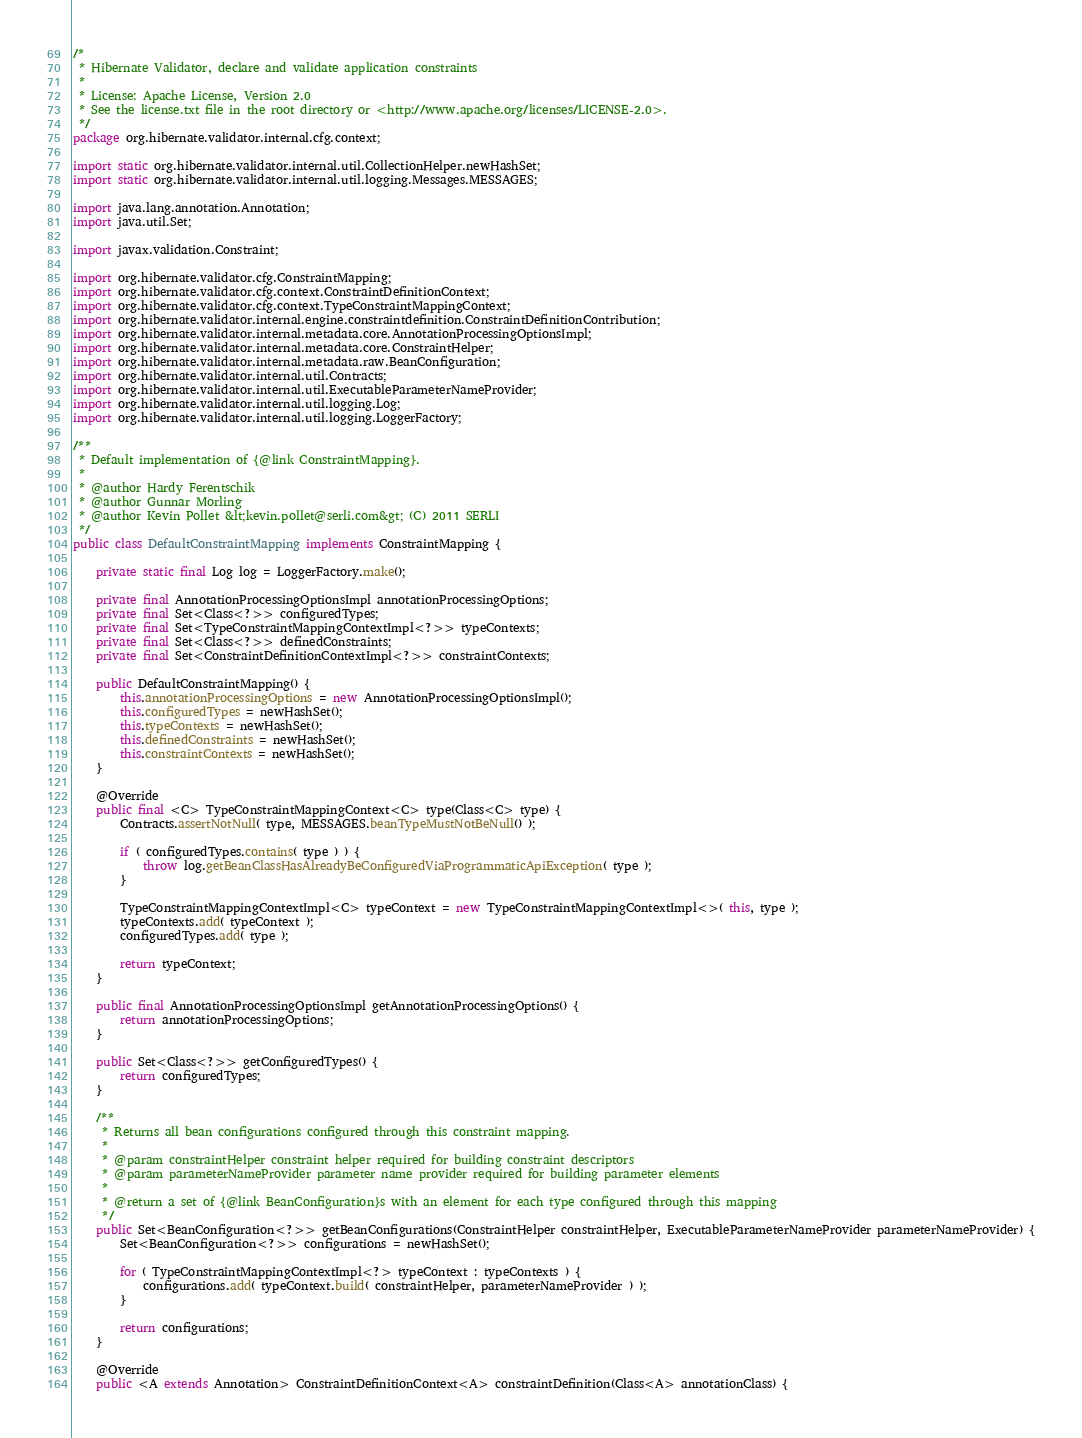<code> <loc_0><loc_0><loc_500><loc_500><_Java_>/*
 * Hibernate Validator, declare and validate application constraints
 *
 * License: Apache License, Version 2.0
 * See the license.txt file in the root directory or <http://www.apache.org/licenses/LICENSE-2.0>.
 */
package org.hibernate.validator.internal.cfg.context;

import static org.hibernate.validator.internal.util.CollectionHelper.newHashSet;
import static org.hibernate.validator.internal.util.logging.Messages.MESSAGES;

import java.lang.annotation.Annotation;
import java.util.Set;

import javax.validation.Constraint;

import org.hibernate.validator.cfg.ConstraintMapping;
import org.hibernate.validator.cfg.context.ConstraintDefinitionContext;
import org.hibernate.validator.cfg.context.TypeConstraintMappingContext;
import org.hibernate.validator.internal.engine.constraintdefinition.ConstraintDefinitionContribution;
import org.hibernate.validator.internal.metadata.core.AnnotationProcessingOptionsImpl;
import org.hibernate.validator.internal.metadata.core.ConstraintHelper;
import org.hibernate.validator.internal.metadata.raw.BeanConfiguration;
import org.hibernate.validator.internal.util.Contracts;
import org.hibernate.validator.internal.util.ExecutableParameterNameProvider;
import org.hibernate.validator.internal.util.logging.Log;
import org.hibernate.validator.internal.util.logging.LoggerFactory;

/**
 * Default implementation of {@link ConstraintMapping}.
 *
 * @author Hardy Ferentschik
 * @author Gunnar Morling
 * @author Kevin Pollet &lt;kevin.pollet@serli.com&gt; (C) 2011 SERLI
 */
public class DefaultConstraintMapping implements ConstraintMapping {

	private static final Log log = LoggerFactory.make();

	private final AnnotationProcessingOptionsImpl annotationProcessingOptions;
	private final Set<Class<?>> configuredTypes;
	private final Set<TypeConstraintMappingContextImpl<?>> typeContexts;
	private final Set<Class<?>> definedConstraints;
	private final Set<ConstraintDefinitionContextImpl<?>> constraintContexts;

	public DefaultConstraintMapping() {
		this.annotationProcessingOptions = new AnnotationProcessingOptionsImpl();
		this.configuredTypes = newHashSet();
		this.typeContexts = newHashSet();
		this.definedConstraints = newHashSet();
		this.constraintContexts = newHashSet();
	}

	@Override
	public final <C> TypeConstraintMappingContext<C> type(Class<C> type) {
		Contracts.assertNotNull( type, MESSAGES.beanTypeMustNotBeNull() );

		if ( configuredTypes.contains( type ) ) {
			throw log.getBeanClassHasAlreadyBeConfiguredViaProgrammaticApiException( type );
		}

		TypeConstraintMappingContextImpl<C> typeContext = new TypeConstraintMappingContextImpl<>( this, type );
		typeContexts.add( typeContext );
		configuredTypes.add( type );

		return typeContext;
	}

	public final AnnotationProcessingOptionsImpl getAnnotationProcessingOptions() {
		return annotationProcessingOptions;
	}

	public Set<Class<?>> getConfiguredTypes() {
		return configuredTypes;
	}

	/**
	 * Returns all bean configurations configured through this constraint mapping.
	 *
	 * @param constraintHelper constraint helper required for building constraint descriptors
	 * @param parameterNameProvider parameter name provider required for building parameter elements
	 *
	 * @return a set of {@link BeanConfiguration}s with an element for each type configured through this mapping
	 */
	public Set<BeanConfiguration<?>> getBeanConfigurations(ConstraintHelper constraintHelper, ExecutableParameterNameProvider parameterNameProvider) {
		Set<BeanConfiguration<?>> configurations = newHashSet();

		for ( TypeConstraintMappingContextImpl<?> typeContext : typeContexts ) {
			configurations.add( typeContext.build( constraintHelper, parameterNameProvider ) );
		}

		return configurations;
	}

	@Override
	public <A extends Annotation> ConstraintDefinitionContext<A> constraintDefinition(Class<A> annotationClass) {</code> 